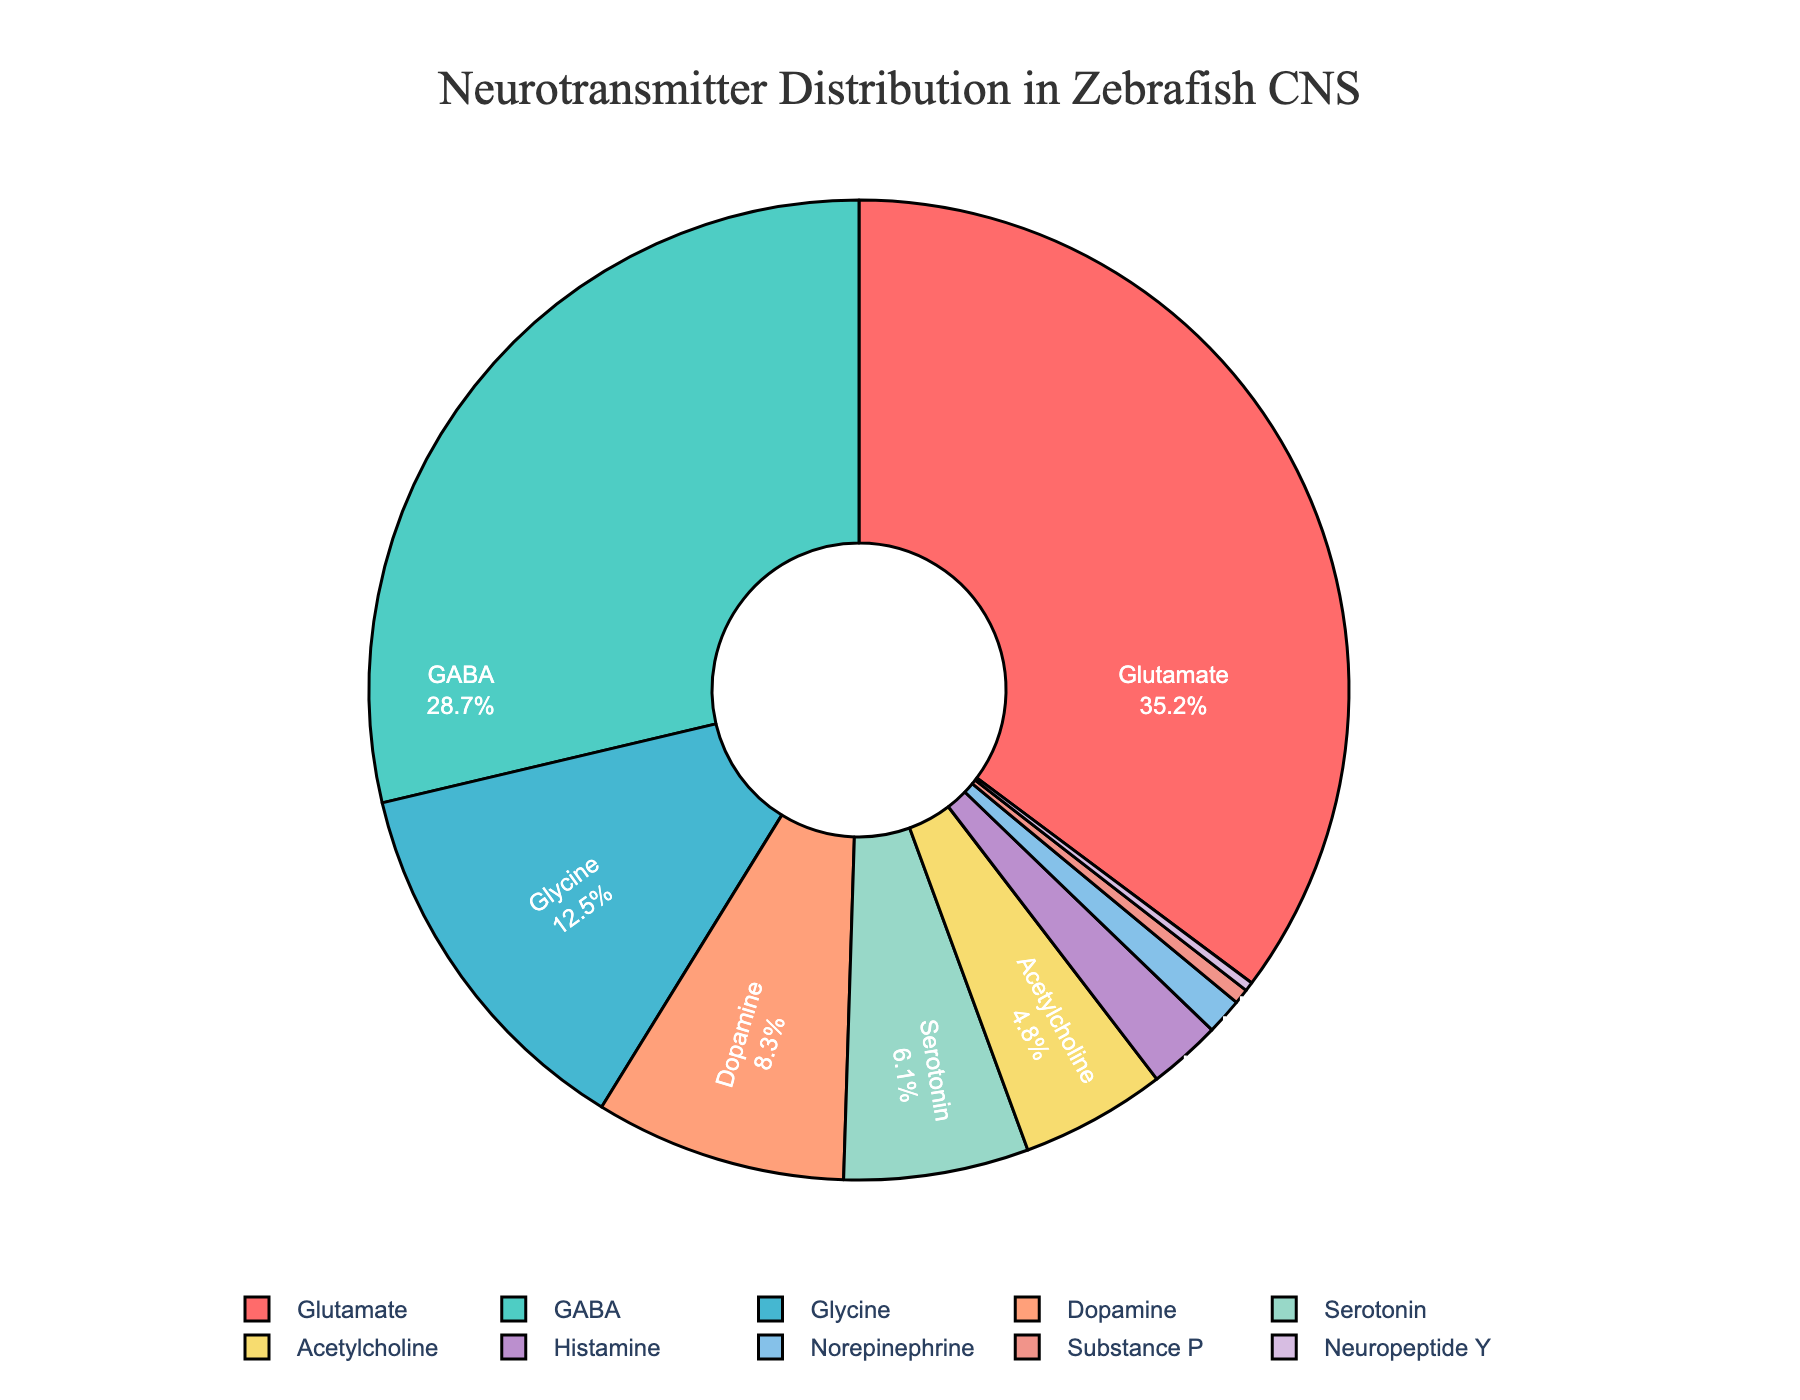What is the most abundant neurotransmitter in the zebrafish central nervous system? The most abundant neurotransmitter is the one represented by the largest section of the pie chart. Glutamate occupies the largest section with 35.2% of the total.
Answer: Glutamate Which neurotransmitter has the smallest proportion? The smallest proportion corresponds to the neurotransmitter represented by the smallest section of the pie chart. Neuropeptide Y occupies the smallest section with 0.3% of the total.
Answer: Neuropeptide Y What is the combined percentage of GABA and Glycine? To find the combined percentage, add the values of GABA and Glycine. GABA has 28.7% and Glycine has 12.5%. The sum is 28.7 + 12.5 = 41.2%.
Answer: 41.2% How does the proportion of Dopamine compare to Serotonin? Comparing the Dopamine and Serotonin segments indicates that Dopamine has a higher percentage. Dopamine is 8.3% while Serotonin is 6.1%.
Answer: Dopamine has a higher proportion Which color represents Histamine in the pie chart? The pie chart uses different colors for different neurotransmitters. Histamine is represented by a purple segment towards the bottom of the chart.
Answer: Purple What is the proportion of all neuropeptides (Substance P and Neuropeptide Y) combined? Add the percentages of Substance P and Neuropeptide Y. Substance P is 0.5% and Neuropeptide Y is 0.3%. The sum is 0.5 + 0.3 = 0.8%.
Answer: 0.8% How much larger is the proportion of Glutamate compared to Norepinephrine? Subtract the percentage of Norepinephrine from Glutamate. Glutamate is 35.2% and Norepinephrine is 1.2%. The difference is 35.2 - 1.2 = 34%.
Answer: 34% Order the neurotransmitters Acetylcholine, Glycine, and Serotonin by their proportions, from largest to smallest. Compare the percentages. Glycine has 12.5%, Serotonin has 6.1%, and Acetylcholine has 4.8%. So, the order from largest to smallest is Glycine, Serotonin, Acetylcholine.
Answer: Glycine, Serotonin, Acetylcholine What is the average percentage of Dopamine, Serotonin, and Norepinephrine? Add the percentages of Dopamine, Serotonin, and Norepinephrine and divide by 3. Dopamine is 8.3%, Serotonin is 6.1%, and Norepinephrine is 1.2%. The sum is 8.3 + 6.1 + 1.2 = 15.6. The average is 15.6 / 3 = 5.2%.
Answer: 5.2% Which neurotransmitters together make up more than 50% of the total proportion? Identify the neurotransmitters whose combined percentages exceed 50%. Adding the largest values starting from the top: Glutamate (35.2%) + GABA (28.7%). The sum is 35.2 + 28.7 = 63.9%.
Answer: Glutamate and GABA 